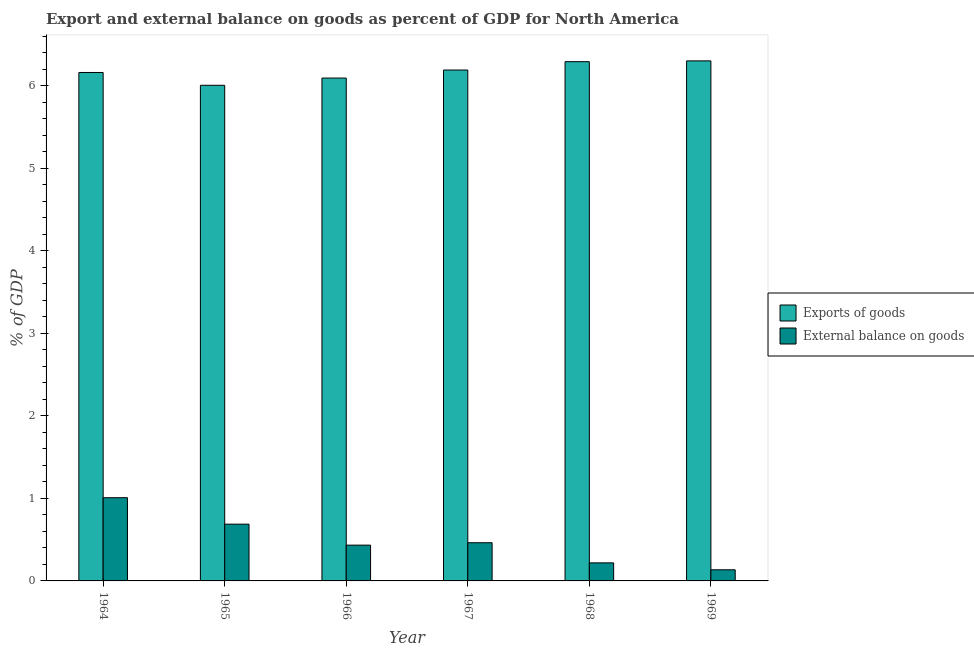How many different coloured bars are there?
Make the answer very short. 2. How many groups of bars are there?
Provide a succinct answer. 6. How many bars are there on the 5th tick from the left?
Provide a short and direct response. 2. How many bars are there on the 6th tick from the right?
Give a very brief answer. 2. What is the label of the 3rd group of bars from the left?
Offer a terse response. 1966. What is the external balance on goods as percentage of gdp in 1964?
Your answer should be very brief. 1.01. Across all years, what is the maximum external balance on goods as percentage of gdp?
Offer a terse response. 1.01. Across all years, what is the minimum external balance on goods as percentage of gdp?
Your answer should be very brief. 0.13. In which year was the export of goods as percentage of gdp maximum?
Offer a terse response. 1969. In which year was the external balance on goods as percentage of gdp minimum?
Make the answer very short. 1969. What is the total external balance on goods as percentage of gdp in the graph?
Keep it short and to the point. 2.95. What is the difference between the external balance on goods as percentage of gdp in 1968 and that in 1969?
Offer a terse response. 0.08. What is the difference between the external balance on goods as percentage of gdp in 1965 and the export of goods as percentage of gdp in 1964?
Provide a succinct answer. -0.32. What is the average external balance on goods as percentage of gdp per year?
Offer a terse response. 0.49. In how many years, is the external balance on goods as percentage of gdp greater than 3 %?
Your response must be concise. 0. What is the ratio of the external balance on goods as percentage of gdp in 1965 to that in 1968?
Ensure brevity in your answer.  3.15. Is the export of goods as percentage of gdp in 1967 less than that in 1968?
Offer a terse response. Yes. Is the difference between the external balance on goods as percentage of gdp in 1965 and 1966 greater than the difference between the export of goods as percentage of gdp in 1965 and 1966?
Your answer should be very brief. No. What is the difference between the highest and the second highest external balance on goods as percentage of gdp?
Offer a very short reply. 0.32. What is the difference between the highest and the lowest external balance on goods as percentage of gdp?
Your response must be concise. 0.87. Is the sum of the export of goods as percentage of gdp in 1965 and 1966 greater than the maximum external balance on goods as percentage of gdp across all years?
Your response must be concise. Yes. What does the 2nd bar from the left in 1966 represents?
Your response must be concise. External balance on goods. What does the 2nd bar from the right in 1966 represents?
Your answer should be very brief. Exports of goods. How many years are there in the graph?
Your answer should be very brief. 6. What is the difference between two consecutive major ticks on the Y-axis?
Give a very brief answer. 1. Are the values on the major ticks of Y-axis written in scientific E-notation?
Your answer should be very brief. No. How are the legend labels stacked?
Provide a succinct answer. Vertical. What is the title of the graph?
Ensure brevity in your answer.  Export and external balance on goods as percent of GDP for North America. What is the label or title of the X-axis?
Your response must be concise. Year. What is the label or title of the Y-axis?
Keep it short and to the point. % of GDP. What is the % of GDP in Exports of goods in 1964?
Your answer should be very brief. 6.16. What is the % of GDP in External balance on goods in 1964?
Offer a very short reply. 1.01. What is the % of GDP of Exports of goods in 1965?
Provide a short and direct response. 6. What is the % of GDP in External balance on goods in 1965?
Provide a succinct answer. 0.69. What is the % of GDP in Exports of goods in 1966?
Provide a short and direct response. 6.09. What is the % of GDP of External balance on goods in 1966?
Ensure brevity in your answer.  0.43. What is the % of GDP in Exports of goods in 1967?
Keep it short and to the point. 6.19. What is the % of GDP of External balance on goods in 1967?
Give a very brief answer. 0.46. What is the % of GDP in Exports of goods in 1968?
Your answer should be compact. 6.29. What is the % of GDP of External balance on goods in 1968?
Make the answer very short. 0.22. What is the % of GDP in Exports of goods in 1969?
Offer a terse response. 6.3. What is the % of GDP of External balance on goods in 1969?
Ensure brevity in your answer.  0.13. Across all years, what is the maximum % of GDP of Exports of goods?
Offer a very short reply. 6.3. Across all years, what is the maximum % of GDP in External balance on goods?
Give a very brief answer. 1.01. Across all years, what is the minimum % of GDP in Exports of goods?
Keep it short and to the point. 6. Across all years, what is the minimum % of GDP in External balance on goods?
Offer a very short reply. 0.13. What is the total % of GDP of Exports of goods in the graph?
Offer a terse response. 37.04. What is the total % of GDP of External balance on goods in the graph?
Your response must be concise. 2.95. What is the difference between the % of GDP of Exports of goods in 1964 and that in 1965?
Offer a very short reply. 0.16. What is the difference between the % of GDP in External balance on goods in 1964 and that in 1965?
Your answer should be compact. 0.32. What is the difference between the % of GDP in Exports of goods in 1964 and that in 1966?
Offer a terse response. 0.07. What is the difference between the % of GDP of External balance on goods in 1964 and that in 1966?
Keep it short and to the point. 0.57. What is the difference between the % of GDP of Exports of goods in 1964 and that in 1967?
Give a very brief answer. -0.03. What is the difference between the % of GDP of External balance on goods in 1964 and that in 1967?
Keep it short and to the point. 0.55. What is the difference between the % of GDP in Exports of goods in 1964 and that in 1968?
Offer a terse response. -0.13. What is the difference between the % of GDP in External balance on goods in 1964 and that in 1968?
Your answer should be very brief. 0.79. What is the difference between the % of GDP in Exports of goods in 1964 and that in 1969?
Provide a short and direct response. -0.14. What is the difference between the % of GDP of External balance on goods in 1964 and that in 1969?
Give a very brief answer. 0.87. What is the difference between the % of GDP in Exports of goods in 1965 and that in 1966?
Give a very brief answer. -0.09. What is the difference between the % of GDP of External balance on goods in 1965 and that in 1966?
Give a very brief answer. 0.25. What is the difference between the % of GDP of Exports of goods in 1965 and that in 1967?
Your answer should be compact. -0.18. What is the difference between the % of GDP of External balance on goods in 1965 and that in 1967?
Give a very brief answer. 0.23. What is the difference between the % of GDP of Exports of goods in 1965 and that in 1968?
Offer a very short reply. -0.29. What is the difference between the % of GDP in External balance on goods in 1965 and that in 1968?
Your answer should be compact. 0.47. What is the difference between the % of GDP of Exports of goods in 1965 and that in 1969?
Offer a very short reply. -0.3. What is the difference between the % of GDP of External balance on goods in 1965 and that in 1969?
Provide a short and direct response. 0.55. What is the difference between the % of GDP of Exports of goods in 1966 and that in 1967?
Your answer should be very brief. -0.1. What is the difference between the % of GDP of External balance on goods in 1966 and that in 1967?
Your answer should be compact. -0.03. What is the difference between the % of GDP of Exports of goods in 1966 and that in 1968?
Keep it short and to the point. -0.2. What is the difference between the % of GDP of External balance on goods in 1966 and that in 1968?
Your answer should be compact. 0.21. What is the difference between the % of GDP in Exports of goods in 1966 and that in 1969?
Make the answer very short. -0.21. What is the difference between the % of GDP in External balance on goods in 1966 and that in 1969?
Offer a terse response. 0.3. What is the difference between the % of GDP of Exports of goods in 1967 and that in 1968?
Keep it short and to the point. -0.1. What is the difference between the % of GDP of External balance on goods in 1967 and that in 1968?
Give a very brief answer. 0.24. What is the difference between the % of GDP of Exports of goods in 1967 and that in 1969?
Ensure brevity in your answer.  -0.11. What is the difference between the % of GDP in External balance on goods in 1967 and that in 1969?
Provide a succinct answer. 0.33. What is the difference between the % of GDP of Exports of goods in 1968 and that in 1969?
Offer a very short reply. -0.01. What is the difference between the % of GDP of External balance on goods in 1968 and that in 1969?
Your answer should be very brief. 0.08. What is the difference between the % of GDP of Exports of goods in 1964 and the % of GDP of External balance on goods in 1965?
Provide a succinct answer. 5.47. What is the difference between the % of GDP in Exports of goods in 1964 and the % of GDP in External balance on goods in 1966?
Provide a succinct answer. 5.73. What is the difference between the % of GDP in Exports of goods in 1964 and the % of GDP in External balance on goods in 1967?
Offer a very short reply. 5.7. What is the difference between the % of GDP in Exports of goods in 1964 and the % of GDP in External balance on goods in 1968?
Your answer should be compact. 5.94. What is the difference between the % of GDP of Exports of goods in 1964 and the % of GDP of External balance on goods in 1969?
Provide a succinct answer. 6.02. What is the difference between the % of GDP in Exports of goods in 1965 and the % of GDP in External balance on goods in 1966?
Offer a very short reply. 5.57. What is the difference between the % of GDP of Exports of goods in 1965 and the % of GDP of External balance on goods in 1967?
Your answer should be compact. 5.54. What is the difference between the % of GDP in Exports of goods in 1965 and the % of GDP in External balance on goods in 1968?
Make the answer very short. 5.79. What is the difference between the % of GDP of Exports of goods in 1965 and the % of GDP of External balance on goods in 1969?
Offer a very short reply. 5.87. What is the difference between the % of GDP of Exports of goods in 1966 and the % of GDP of External balance on goods in 1967?
Ensure brevity in your answer.  5.63. What is the difference between the % of GDP of Exports of goods in 1966 and the % of GDP of External balance on goods in 1968?
Your response must be concise. 5.87. What is the difference between the % of GDP of Exports of goods in 1966 and the % of GDP of External balance on goods in 1969?
Provide a short and direct response. 5.96. What is the difference between the % of GDP in Exports of goods in 1967 and the % of GDP in External balance on goods in 1968?
Keep it short and to the point. 5.97. What is the difference between the % of GDP of Exports of goods in 1967 and the % of GDP of External balance on goods in 1969?
Give a very brief answer. 6.05. What is the difference between the % of GDP in Exports of goods in 1968 and the % of GDP in External balance on goods in 1969?
Offer a terse response. 6.16. What is the average % of GDP of Exports of goods per year?
Your answer should be compact. 6.17. What is the average % of GDP of External balance on goods per year?
Your response must be concise. 0.49. In the year 1964, what is the difference between the % of GDP in Exports of goods and % of GDP in External balance on goods?
Keep it short and to the point. 5.15. In the year 1965, what is the difference between the % of GDP in Exports of goods and % of GDP in External balance on goods?
Ensure brevity in your answer.  5.32. In the year 1966, what is the difference between the % of GDP in Exports of goods and % of GDP in External balance on goods?
Make the answer very short. 5.66. In the year 1967, what is the difference between the % of GDP in Exports of goods and % of GDP in External balance on goods?
Make the answer very short. 5.73. In the year 1968, what is the difference between the % of GDP of Exports of goods and % of GDP of External balance on goods?
Offer a terse response. 6.07. In the year 1969, what is the difference between the % of GDP of Exports of goods and % of GDP of External balance on goods?
Keep it short and to the point. 6.17. What is the ratio of the % of GDP of Exports of goods in 1964 to that in 1965?
Provide a succinct answer. 1.03. What is the ratio of the % of GDP in External balance on goods in 1964 to that in 1965?
Offer a terse response. 1.47. What is the ratio of the % of GDP of Exports of goods in 1964 to that in 1966?
Give a very brief answer. 1.01. What is the ratio of the % of GDP in External balance on goods in 1964 to that in 1966?
Offer a very short reply. 2.33. What is the ratio of the % of GDP of External balance on goods in 1964 to that in 1967?
Your answer should be compact. 2.18. What is the ratio of the % of GDP in Exports of goods in 1964 to that in 1968?
Make the answer very short. 0.98. What is the ratio of the % of GDP of External balance on goods in 1964 to that in 1968?
Give a very brief answer. 4.61. What is the ratio of the % of GDP in Exports of goods in 1964 to that in 1969?
Give a very brief answer. 0.98. What is the ratio of the % of GDP of External balance on goods in 1964 to that in 1969?
Offer a terse response. 7.49. What is the ratio of the % of GDP of Exports of goods in 1965 to that in 1966?
Provide a short and direct response. 0.99. What is the ratio of the % of GDP in External balance on goods in 1965 to that in 1966?
Your answer should be compact. 1.59. What is the ratio of the % of GDP of Exports of goods in 1965 to that in 1967?
Your answer should be very brief. 0.97. What is the ratio of the % of GDP in External balance on goods in 1965 to that in 1967?
Offer a very short reply. 1.49. What is the ratio of the % of GDP of Exports of goods in 1965 to that in 1968?
Give a very brief answer. 0.95. What is the ratio of the % of GDP of External balance on goods in 1965 to that in 1968?
Make the answer very short. 3.15. What is the ratio of the % of GDP of Exports of goods in 1965 to that in 1969?
Make the answer very short. 0.95. What is the ratio of the % of GDP in External balance on goods in 1965 to that in 1969?
Your answer should be compact. 5.11. What is the ratio of the % of GDP of Exports of goods in 1966 to that in 1967?
Your response must be concise. 0.98. What is the ratio of the % of GDP in External balance on goods in 1966 to that in 1967?
Provide a succinct answer. 0.94. What is the ratio of the % of GDP in Exports of goods in 1966 to that in 1968?
Give a very brief answer. 0.97. What is the ratio of the % of GDP of External balance on goods in 1966 to that in 1968?
Your answer should be compact. 1.98. What is the ratio of the % of GDP in Exports of goods in 1966 to that in 1969?
Your answer should be compact. 0.97. What is the ratio of the % of GDP of External balance on goods in 1966 to that in 1969?
Offer a terse response. 3.22. What is the ratio of the % of GDP of Exports of goods in 1967 to that in 1968?
Your answer should be very brief. 0.98. What is the ratio of the % of GDP of External balance on goods in 1967 to that in 1968?
Keep it short and to the point. 2.12. What is the ratio of the % of GDP of Exports of goods in 1967 to that in 1969?
Your response must be concise. 0.98. What is the ratio of the % of GDP of External balance on goods in 1967 to that in 1969?
Your answer should be compact. 3.44. What is the ratio of the % of GDP in Exports of goods in 1968 to that in 1969?
Offer a terse response. 1. What is the ratio of the % of GDP of External balance on goods in 1968 to that in 1969?
Provide a short and direct response. 1.62. What is the difference between the highest and the second highest % of GDP in Exports of goods?
Offer a terse response. 0.01. What is the difference between the highest and the second highest % of GDP of External balance on goods?
Provide a short and direct response. 0.32. What is the difference between the highest and the lowest % of GDP in Exports of goods?
Your response must be concise. 0.3. What is the difference between the highest and the lowest % of GDP in External balance on goods?
Your answer should be very brief. 0.87. 